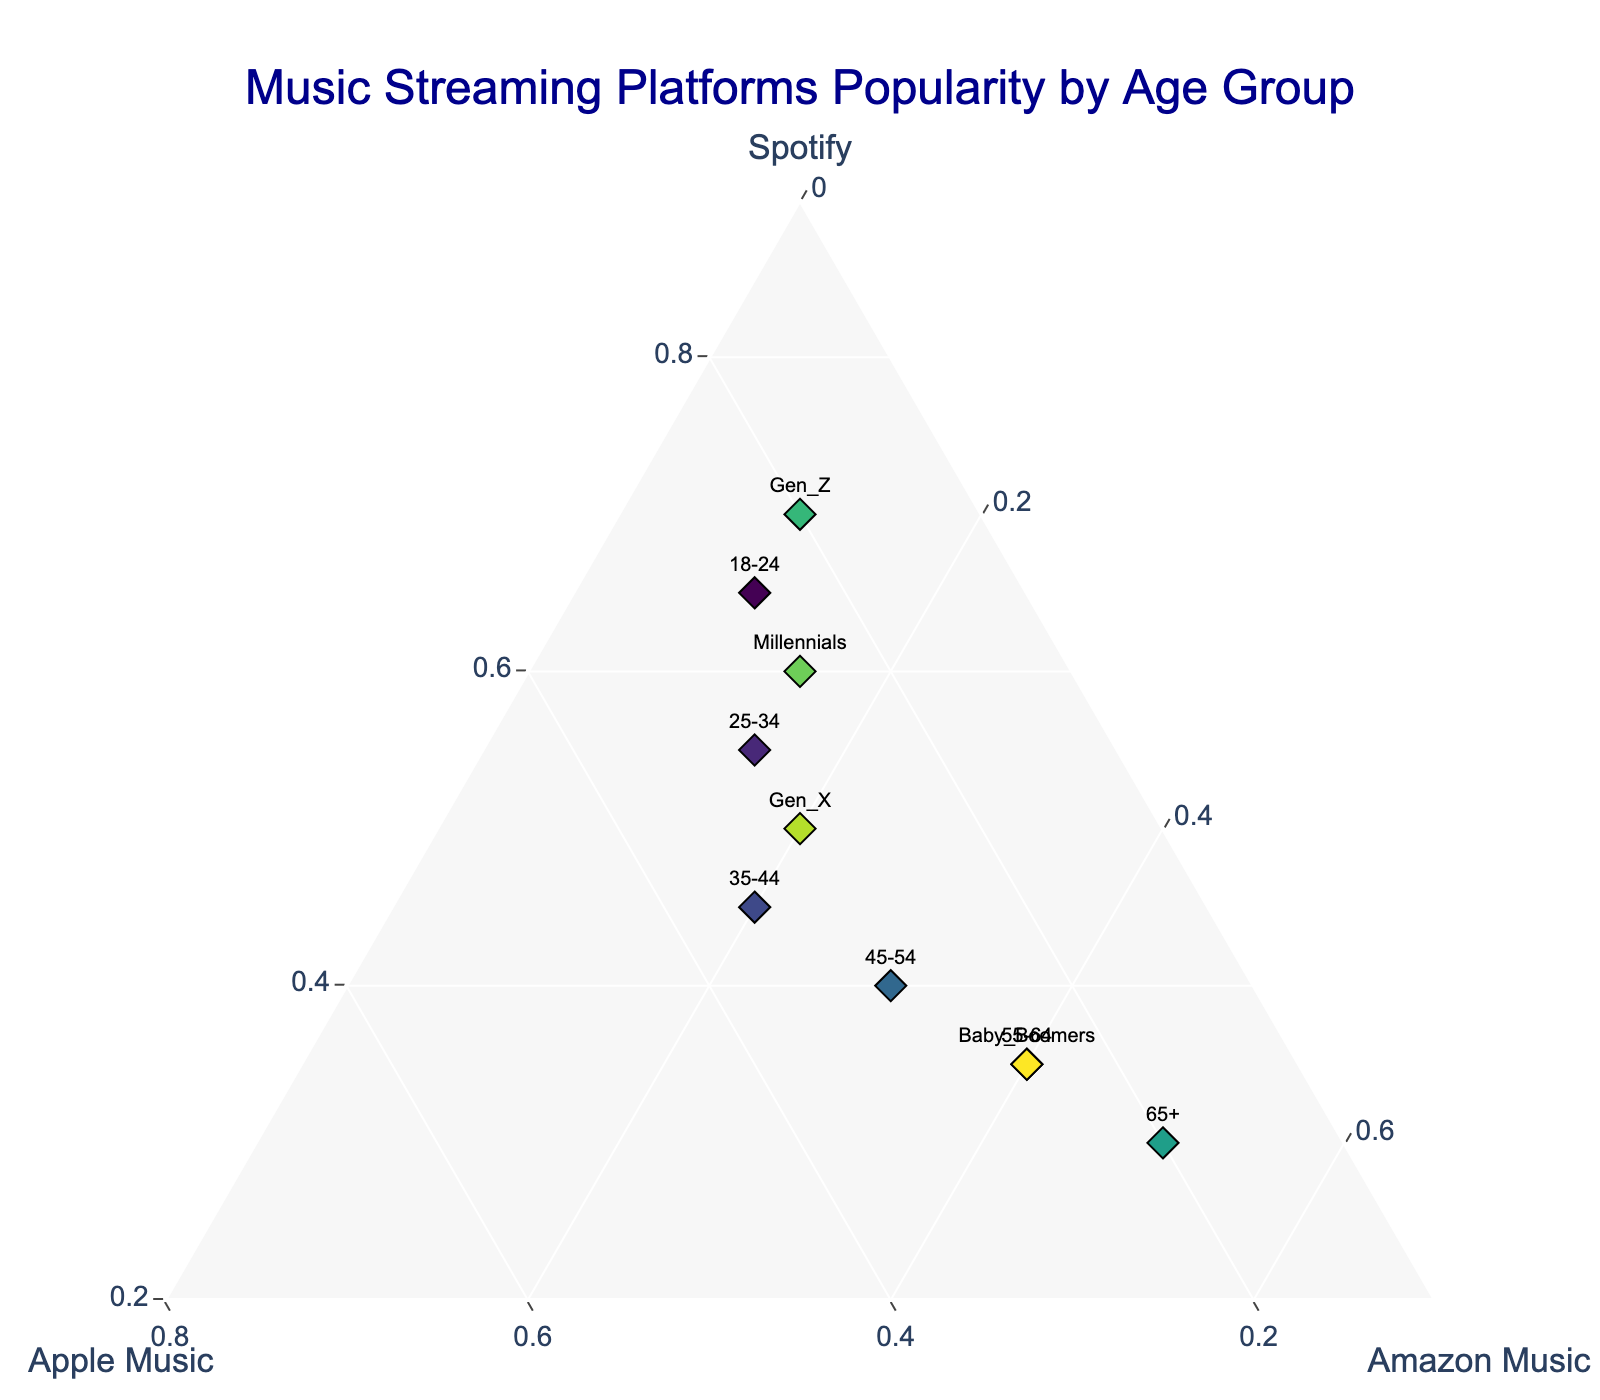What is the title of the plot? The title of the plot is displayed at the top center of the figure. It reads "Music Streaming Platforms Popularity by Age Group".
Answer: Music Streaming Platforms Popularity by Age Group Which age group shows the highest relative popularity for Amazon Music? By observing the horizontal axis labelled Amazon Music, the point farthest to the right corresponds to the age group 65+ where Amazon Music has a relative popularity of 50%.
Answer: 65+ Which age group has nearly equal popularity among all three platforms? Analyze the points closest to the center of the plot, where the relative popularity among Spotify, Apple Music, and Amazon Music is nearly even, which belongs to the age group 45-54.
Answer: 45-54 How does the relative popularity of Spotify differ between Millennials and Baby Boomers? First, identify both points on the plot. Higher relative popularity means the point is closer to the "Spotify" axis. Millennials have a higher relative popularity for Spotify compared to Baby Boomers.
Answer: Millennials have higher relative popularity for Spotify What is the difference in the relative popularity of Apple Music between the 18-24 and 25-34 age groups? Locate both age groups on the plot and consider their position relative to the "Apple Music" axis. Subtract the smaller percentage from the larger one: 30% (25-34) - 25% (18-24) = 5%.
Answer: 5% Which generation group favors Spotify more than the others? The point closest to the "Spotify" axis will have the highest relative popularity for Spotify. The "Gen_Z" group is closest to this axis with a high 70% popularity.
Answer: Gen_Z Does the age group 55-64 show a higher popularity for Spotify or Apple Music? For the age group 55-64, examine which proximity is nearer between "Spotify" and "Apple Music" axes. The graph shows 35% for Spotify and 25% for Apple Music, meaning Spotify is higher.
Answer: Spotify How does the popularity of Amazon Music trend as the age of the group increases? Identify the points along the "Amazon Music" axis; as the age group increases from 18-24 to 65+, the points move from left to right, indicating an increase in popularity.
Answer: Increases Which age group falls at the intersection where all three music streaming platforms have some presence? The age group where its data point resides relatively close to the center of the ternary plot represents the balanced popularity. The age group 25-34 is towards the center with 55% Spotify, 30% Apple Music, and 15% Amazon Music.
Answer: 25-34 